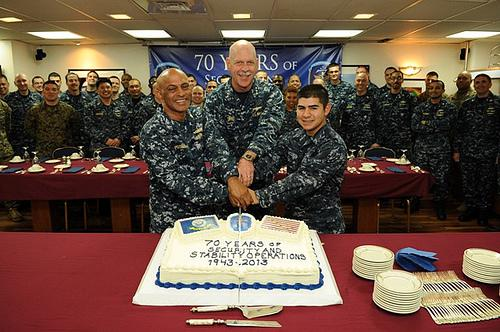Question: what is the color of the cake?
Choices:
A. Blue.
B. Red.
C. White.
D. Green.
Answer with the letter. Answer: C Question: why are the people smiling?
Choices:
A. They heard a funny joke.
B. They are happy.
C. They just finished a good meal.
D. They are friends and haven't seen each other in a long time.
Answer with the letter. Answer: B Question: how many cakes are there?
Choices:
A. 2.
B. 3.
C. 4.
D. 1.
Answer with the letter. Answer: D Question: what is near the cake?
Choices:
A. Forks.
B. Knives.
C. Napkins.
D. Plates.
Answer with the letter. Answer: D 